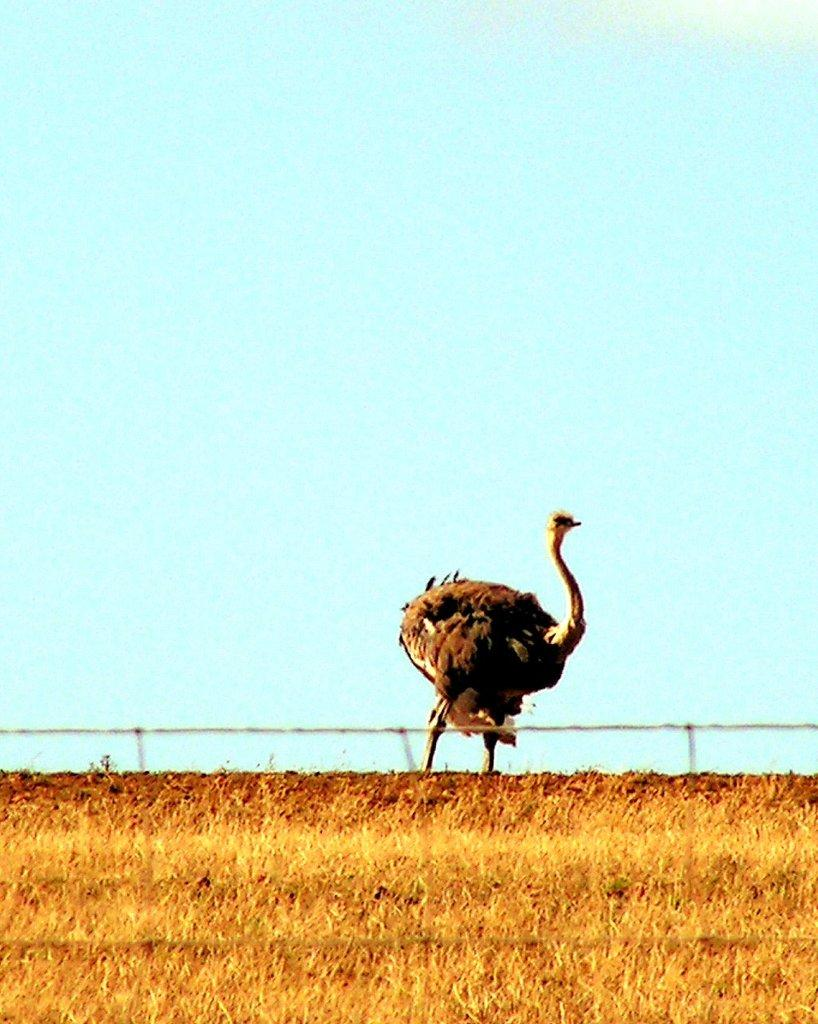What type of vegetation is at the bottom of the image? There is grass at the bottom of the image. What animal can be seen in the middle of the image? There is an ostrich standing in the middle of the image. What part of the natural environment is visible in the background of the image? The sky is visible in the background of the image. Can you tell me how many goldfish are swimming in the grass in the image? There are no goldfish present in the image; it features an ostrich standing in grass with the sky visible in the background. What is the sister of the ostrich doing in the image? There is no mention of a sister in the image, as it only features an ostrich standing in grass with the sky visible in the background. 